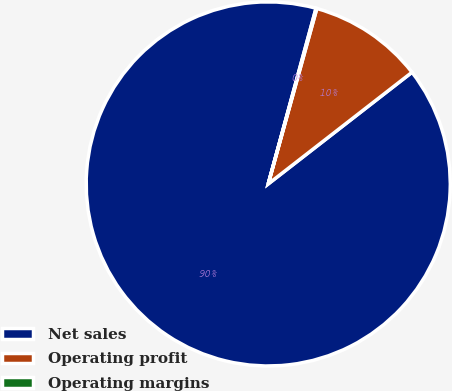<chart> <loc_0><loc_0><loc_500><loc_500><pie_chart><fcel>Net sales<fcel>Operating profit<fcel>Operating margins<nl><fcel>89.74%<fcel>10.19%<fcel>0.07%<nl></chart> 